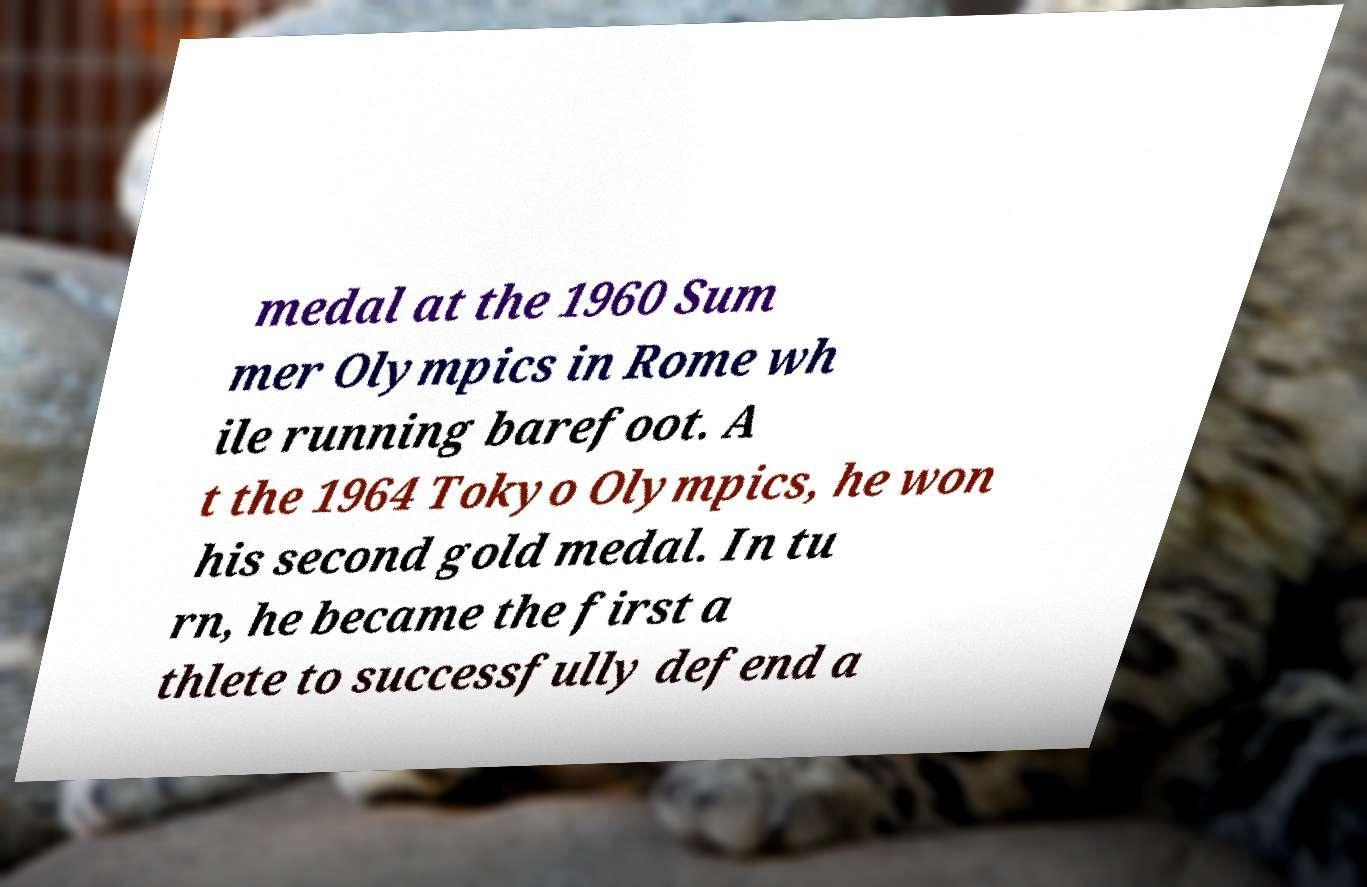Could you assist in decoding the text presented in this image and type it out clearly? medal at the 1960 Sum mer Olympics in Rome wh ile running barefoot. A t the 1964 Tokyo Olympics, he won his second gold medal. In tu rn, he became the first a thlete to successfully defend a 